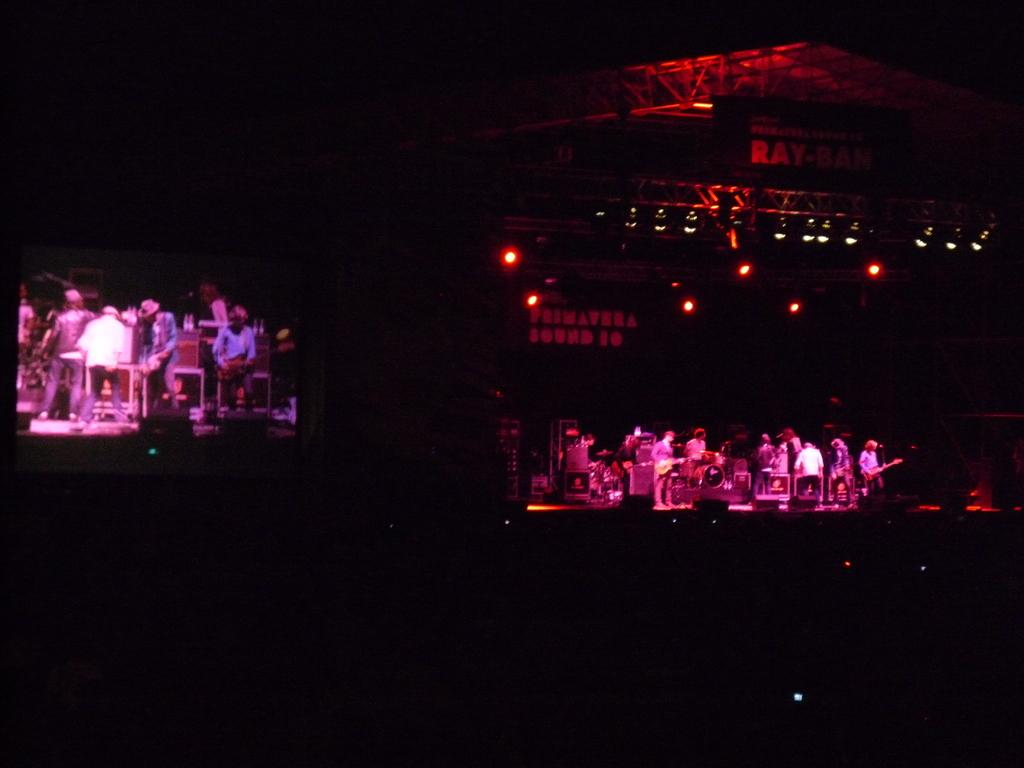How would you describe the overall lighting in the image? The image is dark. What can be seen in the background of the image? There are people, musical instruments, lights, and other objects in the background of the image. Can you tell me how many marks are visible on the musical instruments in the image? There are no marks visible on the musical instruments in the image. How does the clam contribute to the musical performance in the image? There is no clam present in the image, so it cannot contribute to any musical performance. 